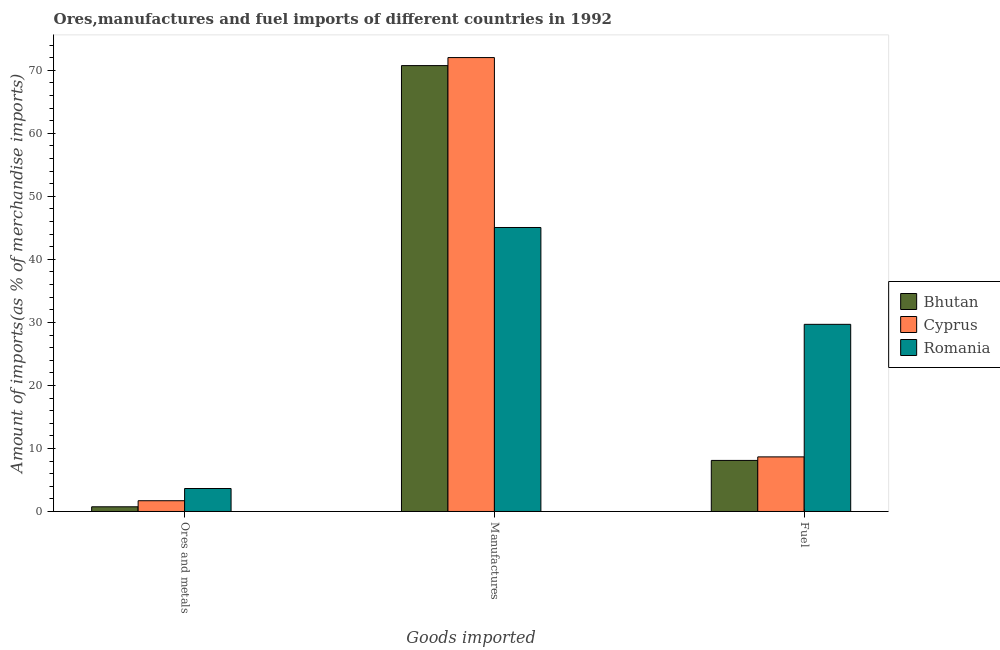How many groups of bars are there?
Offer a very short reply. 3. Are the number of bars per tick equal to the number of legend labels?
Provide a short and direct response. Yes. Are the number of bars on each tick of the X-axis equal?
Your answer should be very brief. Yes. How many bars are there on the 1st tick from the right?
Offer a very short reply. 3. What is the label of the 3rd group of bars from the left?
Provide a succinct answer. Fuel. What is the percentage of fuel imports in Romania?
Offer a terse response. 29.7. Across all countries, what is the maximum percentage of manufactures imports?
Give a very brief answer. 72.02. Across all countries, what is the minimum percentage of ores and metals imports?
Keep it short and to the point. 0.74. In which country was the percentage of ores and metals imports maximum?
Keep it short and to the point. Romania. In which country was the percentage of ores and metals imports minimum?
Ensure brevity in your answer.  Bhutan. What is the total percentage of fuel imports in the graph?
Offer a very short reply. 46.46. What is the difference between the percentage of fuel imports in Bhutan and that in Cyprus?
Make the answer very short. -0.56. What is the difference between the percentage of fuel imports in Cyprus and the percentage of ores and metals imports in Bhutan?
Offer a very short reply. 7.92. What is the average percentage of fuel imports per country?
Provide a succinct answer. 15.49. What is the difference between the percentage of fuel imports and percentage of ores and metals imports in Cyprus?
Offer a very short reply. 6.96. What is the ratio of the percentage of fuel imports in Cyprus to that in Romania?
Offer a very short reply. 0.29. Is the difference between the percentage of manufactures imports in Cyprus and Romania greater than the difference between the percentage of ores and metals imports in Cyprus and Romania?
Give a very brief answer. Yes. What is the difference between the highest and the second highest percentage of ores and metals imports?
Ensure brevity in your answer.  1.94. What is the difference between the highest and the lowest percentage of ores and metals imports?
Offer a very short reply. 2.9. What does the 2nd bar from the left in Fuel represents?
Give a very brief answer. Cyprus. What does the 1st bar from the right in Fuel represents?
Offer a very short reply. Romania. How many bars are there?
Make the answer very short. 9. What is the difference between two consecutive major ticks on the Y-axis?
Keep it short and to the point. 10. Does the graph contain any zero values?
Give a very brief answer. No. How are the legend labels stacked?
Provide a succinct answer. Vertical. What is the title of the graph?
Provide a short and direct response. Ores,manufactures and fuel imports of different countries in 1992. Does "El Salvador" appear as one of the legend labels in the graph?
Give a very brief answer. No. What is the label or title of the X-axis?
Keep it short and to the point. Goods imported. What is the label or title of the Y-axis?
Your response must be concise. Amount of imports(as % of merchandise imports). What is the Amount of imports(as % of merchandise imports) in Bhutan in Ores and metals?
Keep it short and to the point. 0.74. What is the Amount of imports(as % of merchandise imports) of Cyprus in Ores and metals?
Make the answer very short. 1.71. What is the Amount of imports(as % of merchandise imports) in Romania in Ores and metals?
Offer a terse response. 3.65. What is the Amount of imports(as % of merchandise imports) in Bhutan in Manufactures?
Your answer should be very brief. 70.75. What is the Amount of imports(as % of merchandise imports) of Cyprus in Manufactures?
Your answer should be very brief. 72.02. What is the Amount of imports(as % of merchandise imports) in Romania in Manufactures?
Give a very brief answer. 45.06. What is the Amount of imports(as % of merchandise imports) of Bhutan in Fuel?
Your answer should be very brief. 8.1. What is the Amount of imports(as % of merchandise imports) of Cyprus in Fuel?
Your answer should be very brief. 8.66. What is the Amount of imports(as % of merchandise imports) in Romania in Fuel?
Give a very brief answer. 29.7. Across all Goods imported, what is the maximum Amount of imports(as % of merchandise imports) of Bhutan?
Make the answer very short. 70.75. Across all Goods imported, what is the maximum Amount of imports(as % of merchandise imports) of Cyprus?
Your response must be concise. 72.02. Across all Goods imported, what is the maximum Amount of imports(as % of merchandise imports) of Romania?
Ensure brevity in your answer.  45.06. Across all Goods imported, what is the minimum Amount of imports(as % of merchandise imports) of Bhutan?
Make the answer very short. 0.74. Across all Goods imported, what is the minimum Amount of imports(as % of merchandise imports) in Cyprus?
Offer a very short reply. 1.71. Across all Goods imported, what is the minimum Amount of imports(as % of merchandise imports) of Romania?
Offer a very short reply. 3.65. What is the total Amount of imports(as % of merchandise imports) in Bhutan in the graph?
Offer a very short reply. 79.6. What is the total Amount of imports(as % of merchandise imports) in Cyprus in the graph?
Make the answer very short. 82.4. What is the total Amount of imports(as % of merchandise imports) of Romania in the graph?
Offer a very short reply. 78.41. What is the difference between the Amount of imports(as % of merchandise imports) in Bhutan in Ores and metals and that in Manufactures?
Ensure brevity in your answer.  -70.01. What is the difference between the Amount of imports(as % of merchandise imports) of Cyprus in Ores and metals and that in Manufactures?
Your answer should be very brief. -70.32. What is the difference between the Amount of imports(as % of merchandise imports) in Romania in Ores and metals and that in Manufactures?
Offer a very short reply. -41.42. What is the difference between the Amount of imports(as % of merchandise imports) in Bhutan in Ores and metals and that in Fuel?
Offer a terse response. -7.36. What is the difference between the Amount of imports(as % of merchandise imports) of Cyprus in Ores and metals and that in Fuel?
Your answer should be very brief. -6.96. What is the difference between the Amount of imports(as % of merchandise imports) in Romania in Ores and metals and that in Fuel?
Keep it short and to the point. -26.05. What is the difference between the Amount of imports(as % of merchandise imports) of Bhutan in Manufactures and that in Fuel?
Offer a very short reply. 62.65. What is the difference between the Amount of imports(as % of merchandise imports) in Cyprus in Manufactures and that in Fuel?
Make the answer very short. 63.36. What is the difference between the Amount of imports(as % of merchandise imports) in Romania in Manufactures and that in Fuel?
Offer a terse response. 15.37. What is the difference between the Amount of imports(as % of merchandise imports) in Bhutan in Ores and metals and the Amount of imports(as % of merchandise imports) in Cyprus in Manufactures?
Offer a very short reply. -71.28. What is the difference between the Amount of imports(as % of merchandise imports) of Bhutan in Ores and metals and the Amount of imports(as % of merchandise imports) of Romania in Manufactures?
Ensure brevity in your answer.  -44.32. What is the difference between the Amount of imports(as % of merchandise imports) of Cyprus in Ores and metals and the Amount of imports(as % of merchandise imports) of Romania in Manufactures?
Offer a terse response. -43.36. What is the difference between the Amount of imports(as % of merchandise imports) of Bhutan in Ores and metals and the Amount of imports(as % of merchandise imports) of Cyprus in Fuel?
Provide a short and direct response. -7.92. What is the difference between the Amount of imports(as % of merchandise imports) in Bhutan in Ores and metals and the Amount of imports(as % of merchandise imports) in Romania in Fuel?
Your answer should be compact. -28.95. What is the difference between the Amount of imports(as % of merchandise imports) in Cyprus in Ores and metals and the Amount of imports(as % of merchandise imports) in Romania in Fuel?
Make the answer very short. -27.99. What is the difference between the Amount of imports(as % of merchandise imports) in Bhutan in Manufactures and the Amount of imports(as % of merchandise imports) in Cyprus in Fuel?
Give a very brief answer. 62.09. What is the difference between the Amount of imports(as % of merchandise imports) of Bhutan in Manufactures and the Amount of imports(as % of merchandise imports) of Romania in Fuel?
Provide a short and direct response. 41.05. What is the difference between the Amount of imports(as % of merchandise imports) of Cyprus in Manufactures and the Amount of imports(as % of merchandise imports) of Romania in Fuel?
Keep it short and to the point. 42.33. What is the average Amount of imports(as % of merchandise imports) of Bhutan per Goods imported?
Ensure brevity in your answer.  26.53. What is the average Amount of imports(as % of merchandise imports) of Cyprus per Goods imported?
Make the answer very short. 27.47. What is the average Amount of imports(as % of merchandise imports) in Romania per Goods imported?
Keep it short and to the point. 26.14. What is the difference between the Amount of imports(as % of merchandise imports) in Bhutan and Amount of imports(as % of merchandise imports) in Cyprus in Ores and metals?
Provide a succinct answer. -0.96. What is the difference between the Amount of imports(as % of merchandise imports) of Bhutan and Amount of imports(as % of merchandise imports) of Romania in Ores and metals?
Your answer should be very brief. -2.9. What is the difference between the Amount of imports(as % of merchandise imports) of Cyprus and Amount of imports(as % of merchandise imports) of Romania in Ores and metals?
Offer a terse response. -1.94. What is the difference between the Amount of imports(as % of merchandise imports) in Bhutan and Amount of imports(as % of merchandise imports) in Cyprus in Manufactures?
Make the answer very short. -1.27. What is the difference between the Amount of imports(as % of merchandise imports) in Bhutan and Amount of imports(as % of merchandise imports) in Romania in Manufactures?
Give a very brief answer. 25.69. What is the difference between the Amount of imports(as % of merchandise imports) in Cyprus and Amount of imports(as % of merchandise imports) in Romania in Manufactures?
Offer a terse response. 26.96. What is the difference between the Amount of imports(as % of merchandise imports) of Bhutan and Amount of imports(as % of merchandise imports) of Cyprus in Fuel?
Make the answer very short. -0.56. What is the difference between the Amount of imports(as % of merchandise imports) in Bhutan and Amount of imports(as % of merchandise imports) in Romania in Fuel?
Your answer should be compact. -21.59. What is the difference between the Amount of imports(as % of merchandise imports) of Cyprus and Amount of imports(as % of merchandise imports) of Romania in Fuel?
Make the answer very short. -21.03. What is the ratio of the Amount of imports(as % of merchandise imports) in Bhutan in Ores and metals to that in Manufactures?
Keep it short and to the point. 0.01. What is the ratio of the Amount of imports(as % of merchandise imports) of Cyprus in Ores and metals to that in Manufactures?
Keep it short and to the point. 0.02. What is the ratio of the Amount of imports(as % of merchandise imports) of Romania in Ores and metals to that in Manufactures?
Offer a very short reply. 0.08. What is the ratio of the Amount of imports(as % of merchandise imports) in Bhutan in Ores and metals to that in Fuel?
Keep it short and to the point. 0.09. What is the ratio of the Amount of imports(as % of merchandise imports) in Cyprus in Ores and metals to that in Fuel?
Your answer should be very brief. 0.2. What is the ratio of the Amount of imports(as % of merchandise imports) in Romania in Ores and metals to that in Fuel?
Your answer should be compact. 0.12. What is the ratio of the Amount of imports(as % of merchandise imports) of Bhutan in Manufactures to that in Fuel?
Offer a very short reply. 8.73. What is the ratio of the Amount of imports(as % of merchandise imports) of Cyprus in Manufactures to that in Fuel?
Your response must be concise. 8.31. What is the ratio of the Amount of imports(as % of merchandise imports) in Romania in Manufactures to that in Fuel?
Your answer should be compact. 1.52. What is the difference between the highest and the second highest Amount of imports(as % of merchandise imports) of Bhutan?
Offer a very short reply. 62.65. What is the difference between the highest and the second highest Amount of imports(as % of merchandise imports) in Cyprus?
Provide a succinct answer. 63.36. What is the difference between the highest and the second highest Amount of imports(as % of merchandise imports) of Romania?
Your answer should be compact. 15.37. What is the difference between the highest and the lowest Amount of imports(as % of merchandise imports) of Bhutan?
Offer a very short reply. 70.01. What is the difference between the highest and the lowest Amount of imports(as % of merchandise imports) in Cyprus?
Make the answer very short. 70.32. What is the difference between the highest and the lowest Amount of imports(as % of merchandise imports) of Romania?
Your response must be concise. 41.42. 